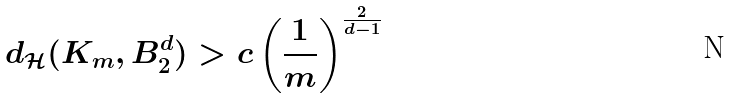<formula> <loc_0><loc_0><loc_500><loc_500>d _ { \mathcal { H } } ( K _ { m } , B _ { 2 } ^ { d } ) > c \left ( \frac { 1 } { m } \right ) ^ { \frac { 2 } { d - 1 } }</formula> 